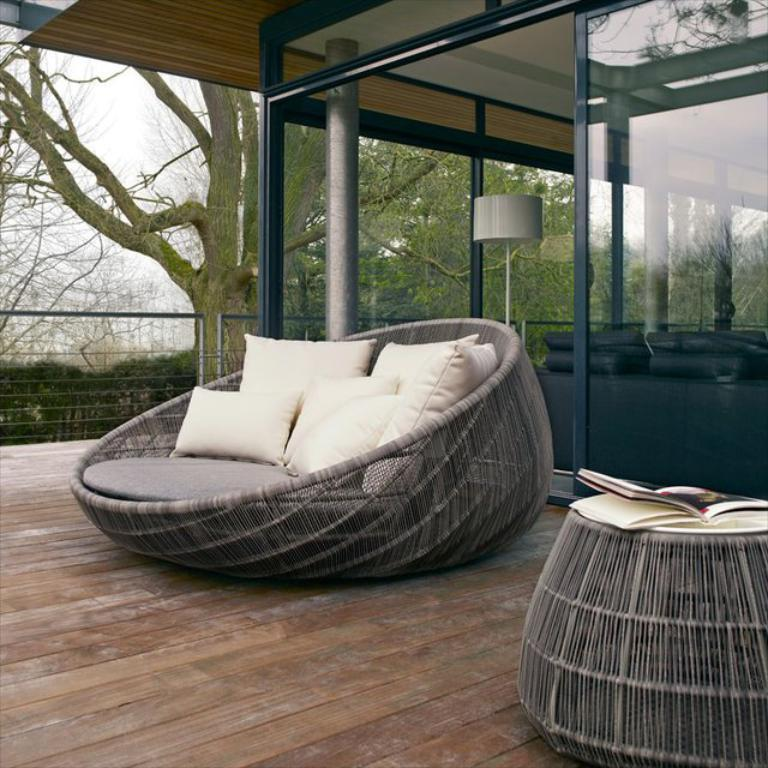What object can be seen on the table in the image? There is a cushion and a book on the table in the image. What is the purpose of the cushion and book on the table? The purpose of the cushion and book is not specified in the image. What can be seen in the background of the image? There is a lamp, a sofa set, and trees visible in the background of the image. How many pizzas are being served on the side of the table in the image? There are no pizzas present in the image. What type of attraction is visible in the background of the image? There is no attraction visible in the background of the image; only a lamp, a sofa set, and trees are present. 